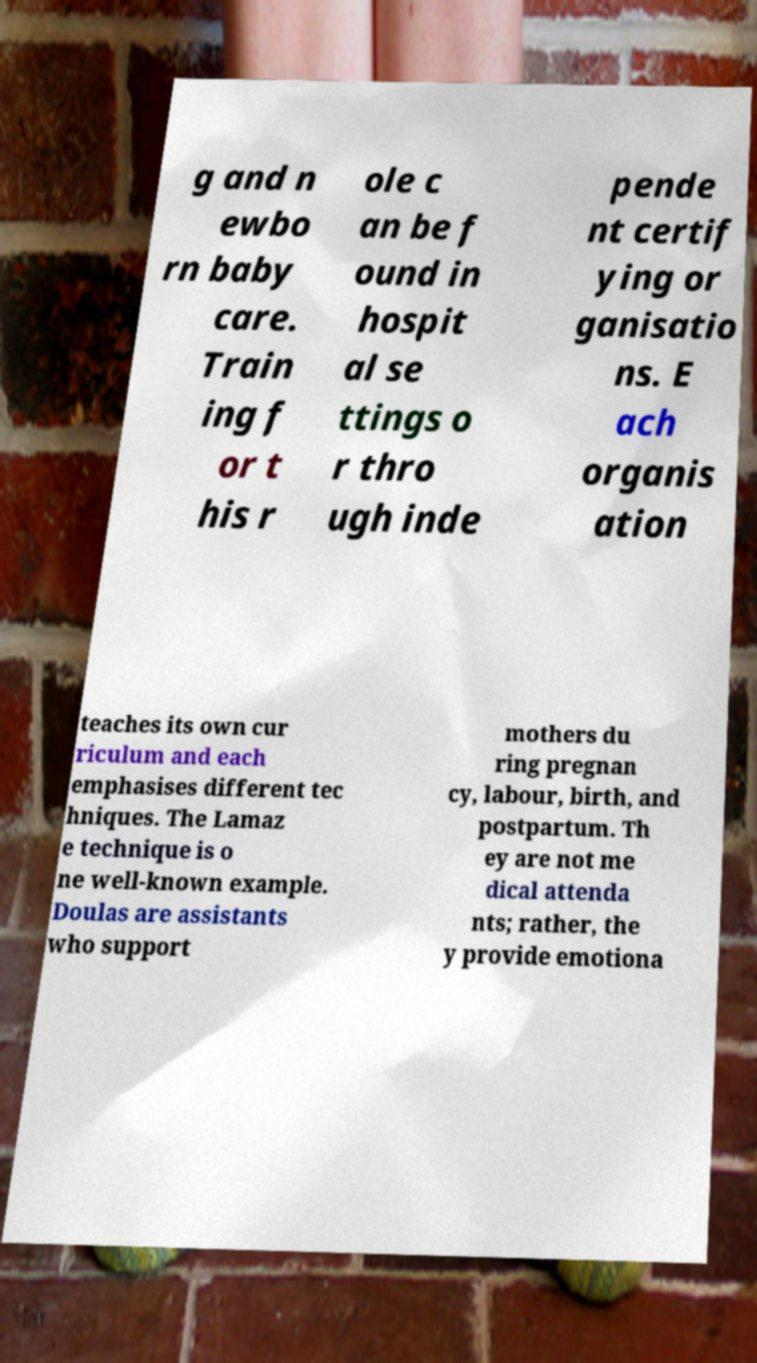For documentation purposes, I need the text within this image transcribed. Could you provide that? g and n ewbo rn baby care. Train ing f or t his r ole c an be f ound in hospit al se ttings o r thro ugh inde pende nt certif ying or ganisatio ns. E ach organis ation teaches its own cur riculum and each emphasises different tec hniques. The Lamaz e technique is o ne well-known example. Doulas are assistants who support mothers du ring pregnan cy, labour, birth, and postpartum. Th ey are not me dical attenda nts; rather, the y provide emotiona 